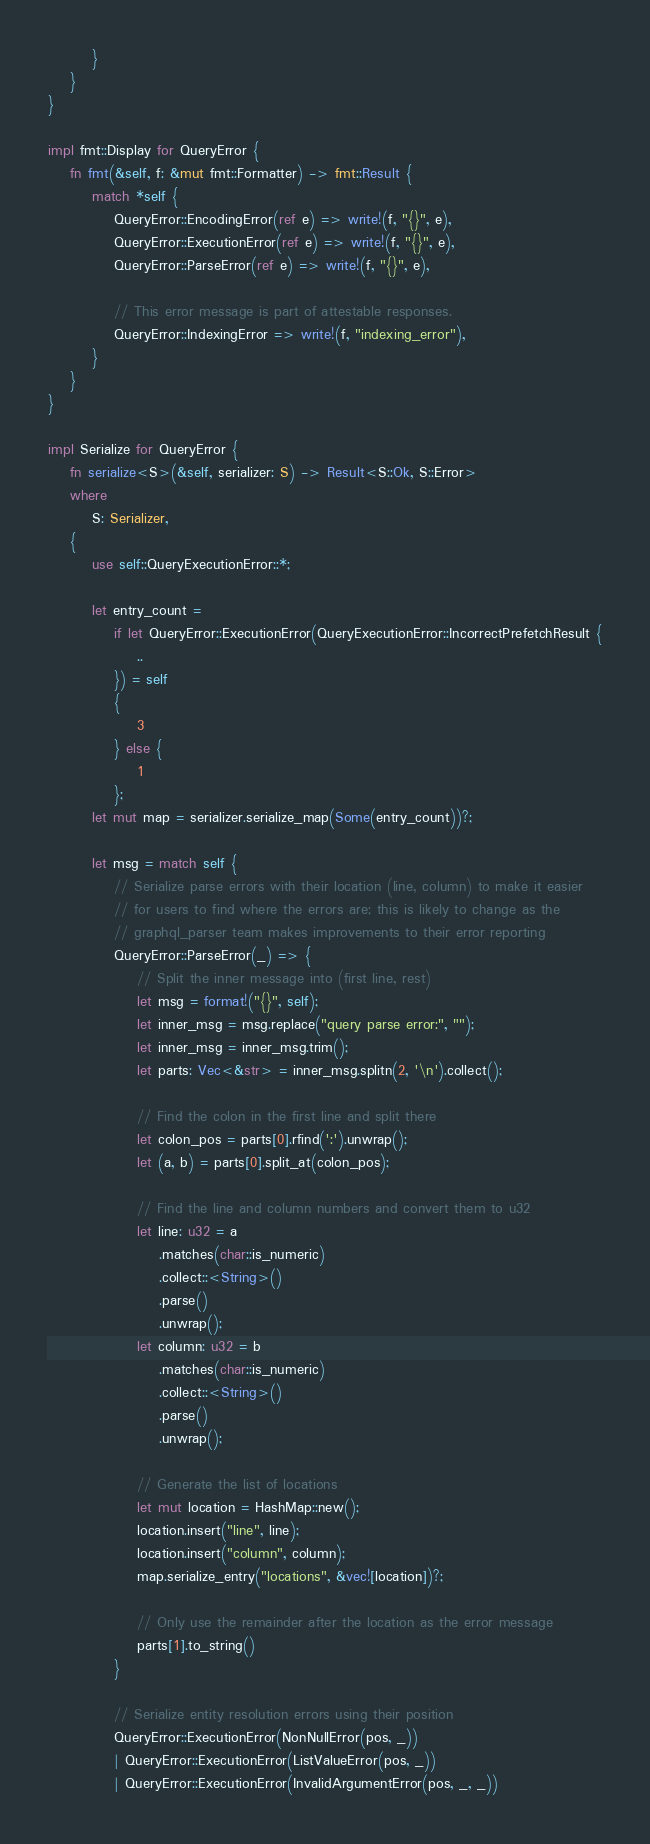Convert code to text. <code><loc_0><loc_0><loc_500><loc_500><_Rust_>        }
    }
}

impl fmt::Display for QueryError {
    fn fmt(&self, f: &mut fmt::Formatter) -> fmt::Result {
        match *self {
            QueryError::EncodingError(ref e) => write!(f, "{}", e),
            QueryError::ExecutionError(ref e) => write!(f, "{}", e),
            QueryError::ParseError(ref e) => write!(f, "{}", e),

            // This error message is part of attestable responses.
            QueryError::IndexingError => write!(f, "indexing_error"),
        }
    }
}

impl Serialize for QueryError {
    fn serialize<S>(&self, serializer: S) -> Result<S::Ok, S::Error>
    where
        S: Serializer,
    {
        use self::QueryExecutionError::*;

        let entry_count =
            if let QueryError::ExecutionError(QueryExecutionError::IncorrectPrefetchResult {
                ..
            }) = self
            {
                3
            } else {
                1
            };
        let mut map = serializer.serialize_map(Some(entry_count))?;

        let msg = match self {
            // Serialize parse errors with their location (line, column) to make it easier
            // for users to find where the errors are; this is likely to change as the
            // graphql_parser team makes improvements to their error reporting
            QueryError::ParseError(_) => {
                // Split the inner message into (first line, rest)
                let msg = format!("{}", self);
                let inner_msg = msg.replace("query parse error:", "");
                let inner_msg = inner_msg.trim();
                let parts: Vec<&str> = inner_msg.splitn(2, '\n').collect();

                // Find the colon in the first line and split there
                let colon_pos = parts[0].rfind(':').unwrap();
                let (a, b) = parts[0].split_at(colon_pos);

                // Find the line and column numbers and convert them to u32
                let line: u32 = a
                    .matches(char::is_numeric)
                    .collect::<String>()
                    .parse()
                    .unwrap();
                let column: u32 = b
                    .matches(char::is_numeric)
                    .collect::<String>()
                    .parse()
                    .unwrap();

                // Generate the list of locations
                let mut location = HashMap::new();
                location.insert("line", line);
                location.insert("column", column);
                map.serialize_entry("locations", &vec![location])?;

                // Only use the remainder after the location as the error message
                parts[1].to_string()
            }

            // Serialize entity resolution errors using their position
            QueryError::ExecutionError(NonNullError(pos, _))
            | QueryError::ExecutionError(ListValueError(pos, _))
            | QueryError::ExecutionError(InvalidArgumentError(pos, _, _))</code> 